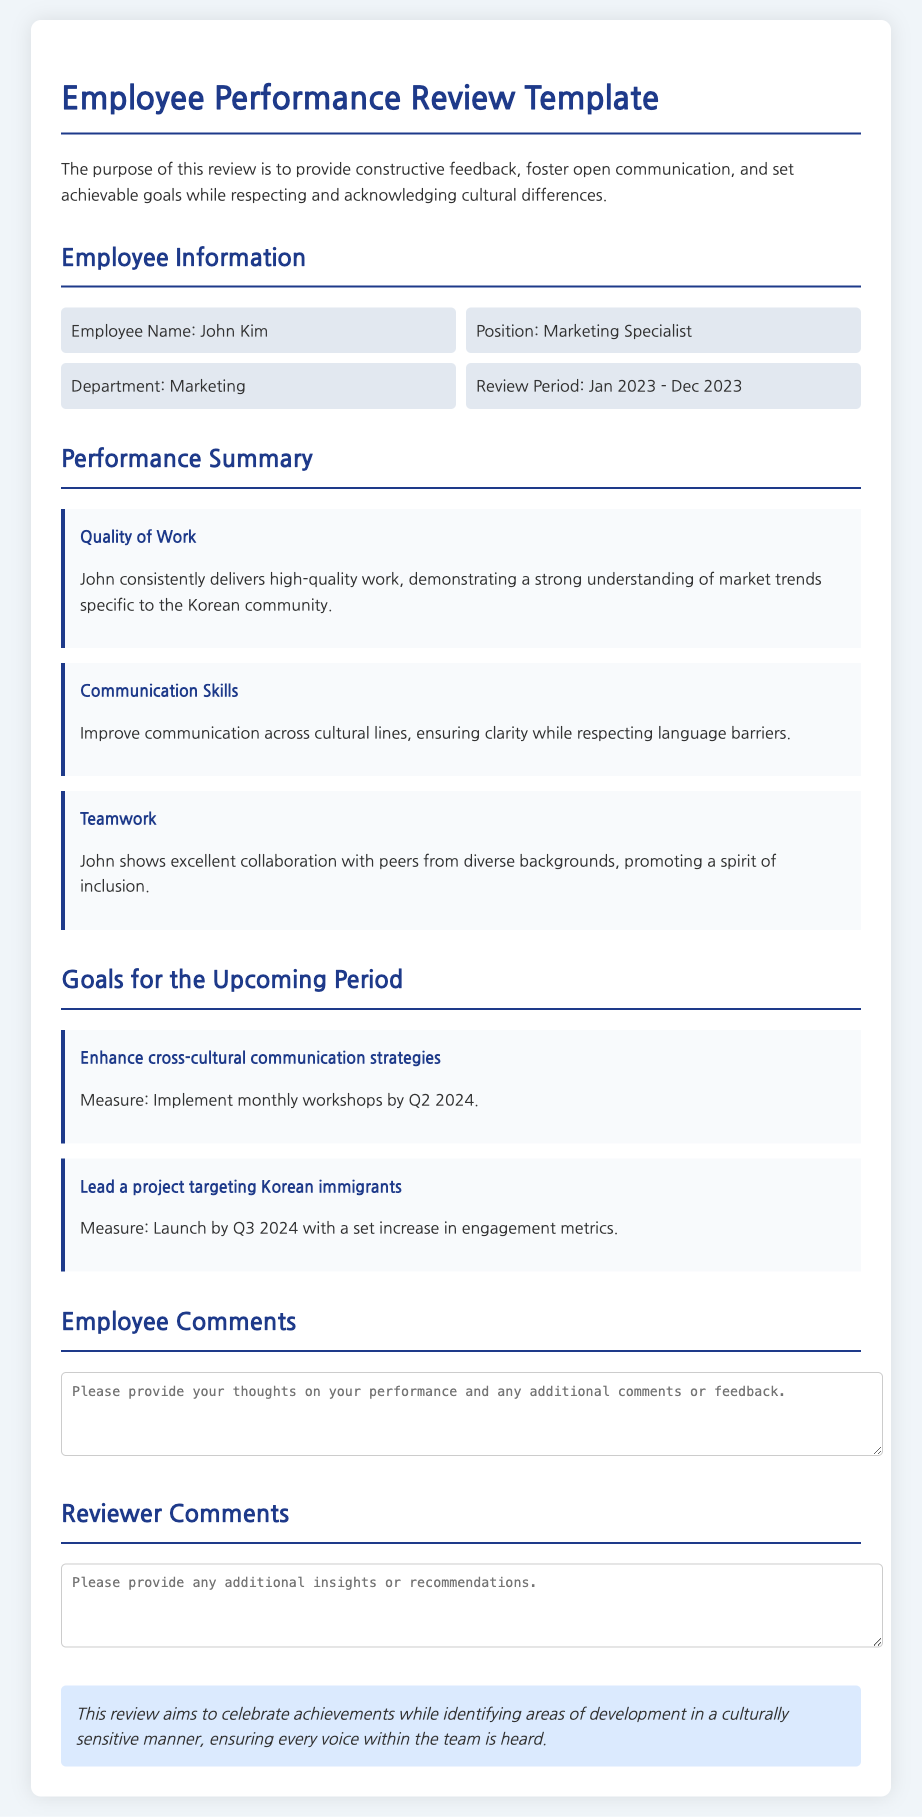What is the employee's name? The document states the employee's name in the Employee Information section.
Answer: John Kim What position does John Kim hold? The document specifies the employee's position as provided in the Employee Information section.
Answer: Marketing Specialist What department is John Kim in? The employee's department is clearly mentioned in the Employee Information section.
Answer: Marketing What is the review period for John Kim? The review period is provided in the Employee Information section of the document.
Answer: Jan 2023 - Dec 2023 What aspect received the highest praise in the Performance Summary? The Performance Summary highlights the Quality of Work as an area of strength.
Answer: Quality of Work What goal is set to enhance cross-cultural communication? The document outlines specific goals aimed at cross-cultural communication in the Goals section.
Answer: Enhance cross-cultural communication strategies How many workshops are planned to be implemented by Q2 2024? The goal to enhance communication strategies specifies the implementation of monthly workshops.
Answer: Monthly workshops What is one of the measures for the project targeting Korean immigrants? The measure associated with the project targeting Korean immigrants is indicated within the Goals section.
Answer: Launch by Q3 2024 What is a key document aim mentioned in the conclusion? The conclusion outlines the primary aim of providing feedback and setting goals while respecting culture.
Answer: Celebrate achievements 